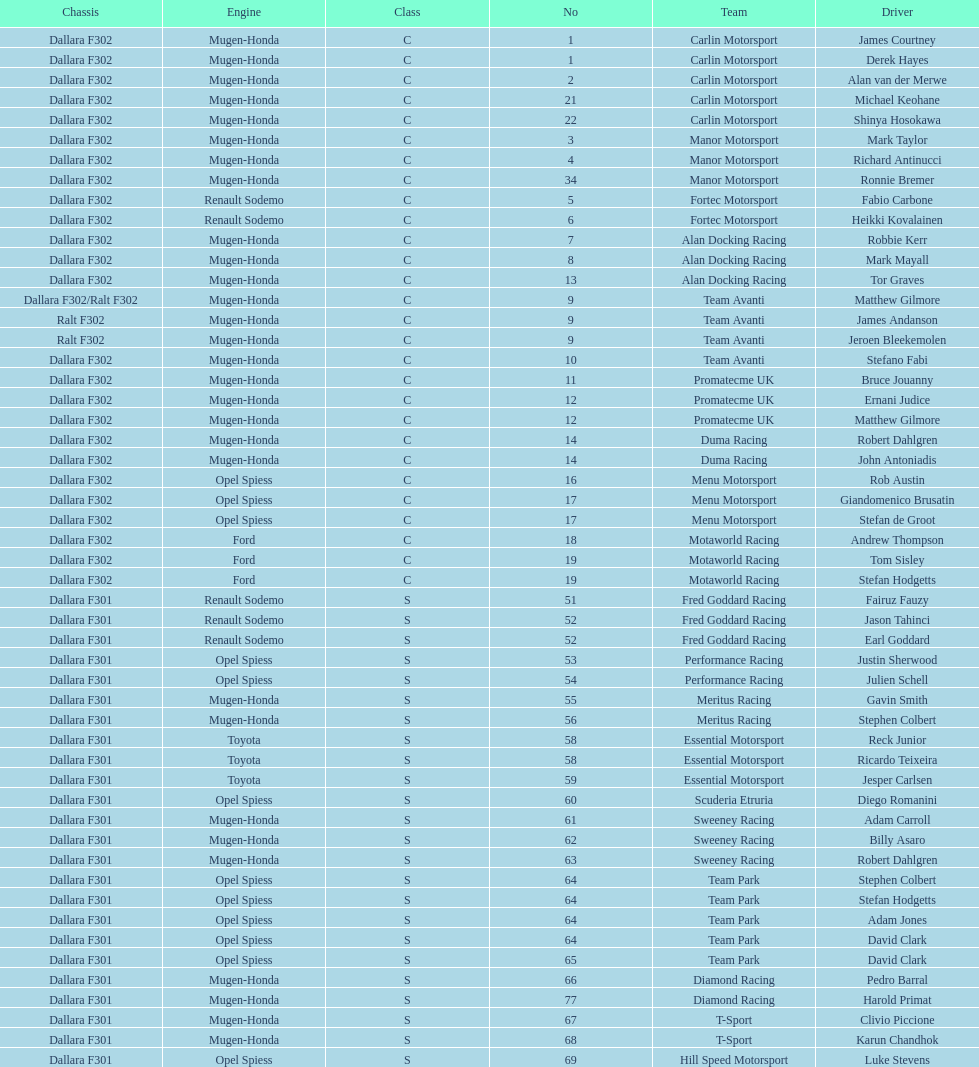What is the average number of teams that had a mugen-honda engine? 24. 